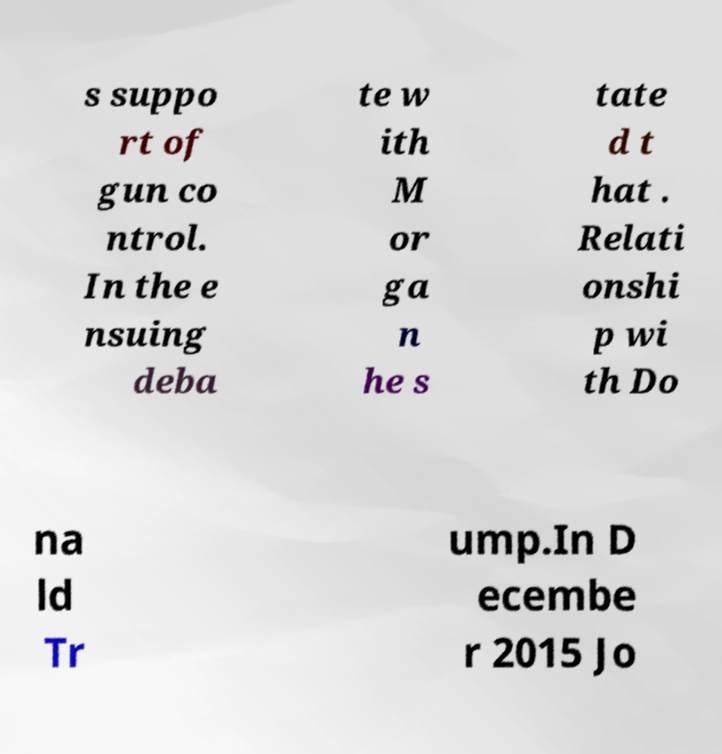Please read and relay the text visible in this image. What does it say? s suppo rt of gun co ntrol. In the e nsuing deba te w ith M or ga n he s tate d t hat . Relati onshi p wi th Do na ld Tr ump.In D ecembe r 2015 Jo 